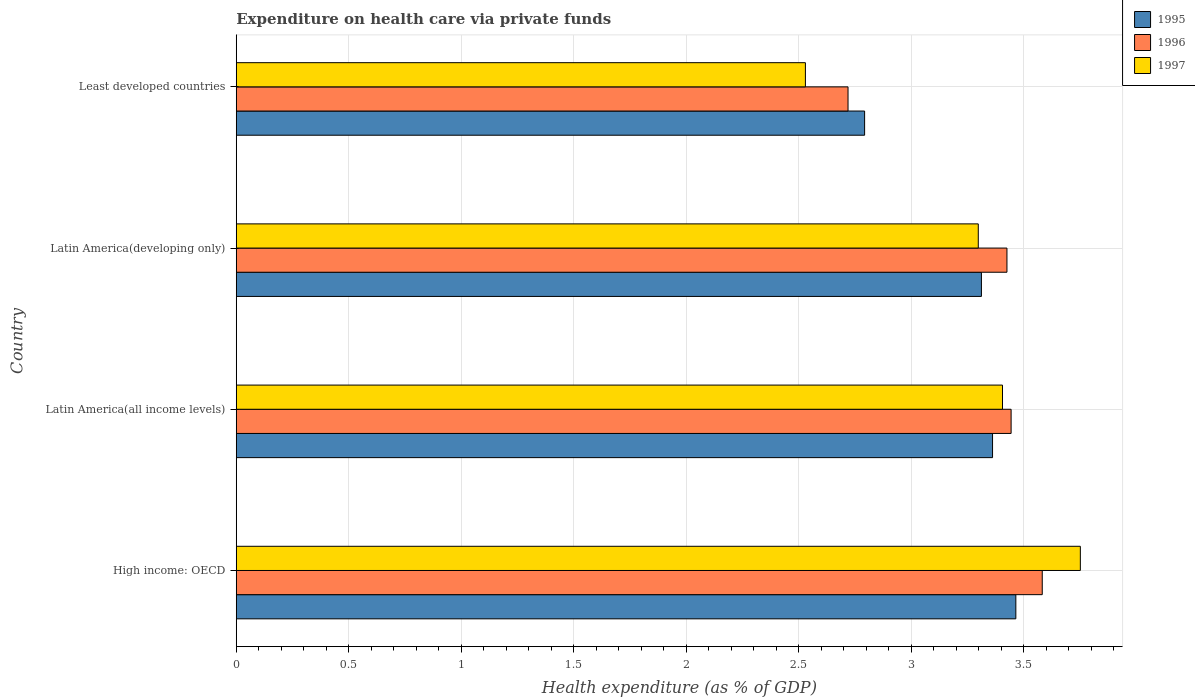How many different coloured bars are there?
Offer a very short reply. 3. Are the number of bars per tick equal to the number of legend labels?
Ensure brevity in your answer.  Yes. Are the number of bars on each tick of the Y-axis equal?
Your answer should be very brief. Yes. How many bars are there on the 3rd tick from the top?
Give a very brief answer. 3. How many bars are there on the 4th tick from the bottom?
Offer a terse response. 3. What is the label of the 1st group of bars from the top?
Provide a succinct answer. Least developed countries. In how many cases, is the number of bars for a given country not equal to the number of legend labels?
Provide a short and direct response. 0. What is the expenditure made on health care in 1997 in Latin America(all income levels)?
Your response must be concise. 3.41. Across all countries, what is the maximum expenditure made on health care in 1996?
Keep it short and to the point. 3.58. Across all countries, what is the minimum expenditure made on health care in 1996?
Offer a very short reply. 2.72. In which country was the expenditure made on health care in 1996 maximum?
Provide a short and direct response. High income: OECD. In which country was the expenditure made on health care in 1997 minimum?
Provide a short and direct response. Least developed countries. What is the total expenditure made on health care in 1995 in the graph?
Provide a short and direct response. 12.93. What is the difference between the expenditure made on health care in 1997 in Latin America(developing only) and that in Least developed countries?
Your answer should be very brief. 0.77. What is the difference between the expenditure made on health care in 1995 in Latin America(all income levels) and the expenditure made on health care in 1996 in Latin America(developing only)?
Offer a terse response. -0.06. What is the average expenditure made on health care in 1996 per country?
Your response must be concise. 3.29. What is the difference between the expenditure made on health care in 1995 and expenditure made on health care in 1996 in Least developed countries?
Provide a short and direct response. 0.07. What is the ratio of the expenditure made on health care in 1995 in Latin America(developing only) to that in Least developed countries?
Your answer should be compact. 1.19. What is the difference between the highest and the second highest expenditure made on health care in 1995?
Give a very brief answer. 0.1. What is the difference between the highest and the lowest expenditure made on health care in 1996?
Your response must be concise. 0.86. What does the 2nd bar from the top in Least developed countries represents?
Your response must be concise. 1996. What does the 3rd bar from the bottom in High income: OECD represents?
Offer a very short reply. 1997. Is it the case that in every country, the sum of the expenditure made on health care in 1997 and expenditure made on health care in 1996 is greater than the expenditure made on health care in 1995?
Your answer should be very brief. Yes. How many bars are there?
Provide a short and direct response. 12. What is the difference between two consecutive major ticks on the X-axis?
Provide a succinct answer. 0.5. Does the graph contain grids?
Make the answer very short. Yes. How many legend labels are there?
Make the answer very short. 3. What is the title of the graph?
Offer a very short reply. Expenditure on health care via private funds. Does "1978" appear as one of the legend labels in the graph?
Give a very brief answer. No. What is the label or title of the X-axis?
Your answer should be compact. Health expenditure (as % of GDP). What is the label or title of the Y-axis?
Your response must be concise. Country. What is the Health expenditure (as % of GDP) in 1995 in High income: OECD?
Offer a very short reply. 3.47. What is the Health expenditure (as % of GDP) of 1996 in High income: OECD?
Ensure brevity in your answer.  3.58. What is the Health expenditure (as % of GDP) of 1997 in High income: OECD?
Offer a terse response. 3.75. What is the Health expenditure (as % of GDP) in 1995 in Latin America(all income levels)?
Keep it short and to the point. 3.36. What is the Health expenditure (as % of GDP) in 1996 in Latin America(all income levels)?
Your answer should be compact. 3.44. What is the Health expenditure (as % of GDP) of 1997 in Latin America(all income levels)?
Your response must be concise. 3.41. What is the Health expenditure (as % of GDP) in 1995 in Latin America(developing only)?
Your answer should be very brief. 3.31. What is the Health expenditure (as % of GDP) of 1996 in Latin America(developing only)?
Ensure brevity in your answer.  3.43. What is the Health expenditure (as % of GDP) of 1997 in Latin America(developing only)?
Ensure brevity in your answer.  3.3. What is the Health expenditure (as % of GDP) in 1995 in Least developed countries?
Provide a short and direct response. 2.79. What is the Health expenditure (as % of GDP) in 1996 in Least developed countries?
Your response must be concise. 2.72. What is the Health expenditure (as % of GDP) in 1997 in Least developed countries?
Offer a very short reply. 2.53. Across all countries, what is the maximum Health expenditure (as % of GDP) in 1995?
Offer a very short reply. 3.47. Across all countries, what is the maximum Health expenditure (as % of GDP) of 1996?
Your answer should be compact. 3.58. Across all countries, what is the maximum Health expenditure (as % of GDP) in 1997?
Offer a terse response. 3.75. Across all countries, what is the minimum Health expenditure (as % of GDP) of 1995?
Offer a terse response. 2.79. Across all countries, what is the minimum Health expenditure (as % of GDP) in 1996?
Your response must be concise. 2.72. Across all countries, what is the minimum Health expenditure (as % of GDP) in 1997?
Make the answer very short. 2.53. What is the total Health expenditure (as % of GDP) of 1995 in the graph?
Your answer should be compact. 12.93. What is the total Health expenditure (as % of GDP) in 1996 in the graph?
Keep it short and to the point. 13.17. What is the total Health expenditure (as % of GDP) in 1997 in the graph?
Keep it short and to the point. 12.99. What is the difference between the Health expenditure (as % of GDP) in 1995 in High income: OECD and that in Latin America(all income levels)?
Your response must be concise. 0.1. What is the difference between the Health expenditure (as % of GDP) of 1996 in High income: OECD and that in Latin America(all income levels)?
Your answer should be compact. 0.14. What is the difference between the Health expenditure (as % of GDP) in 1997 in High income: OECD and that in Latin America(all income levels)?
Provide a succinct answer. 0.35. What is the difference between the Health expenditure (as % of GDP) in 1995 in High income: OECD and that in Latin America(developing only)?
Your answer should be compact. 0.15. What is the difference between the Health expenditure (as % of GDP) in 1996 in High income: OECD and that in Latin America(developing only)?
Give a very brief answer. 0.16. What is the difference between the Health expenditure (as % of GDP) of 1997 in High income: OECD and that in Latin America(developing only)?
Make the answer very short. 0.45. What is the difference between the Health expenditure (as % of GDP) in 1995 in High income: OECD and that in Least developed countries?
Offer a very short reply. 0.67. What is the difference between the Health expenditure (as % of GDP) in 1996 in High income: OECD and that in Least developed countries?
Give a very brief answer. 0.86. What is the difference between the Health expenditure (as % of GDP) in 1997 in High income: OECD and that in Least developed countries?
Your response must be concise. 1.22. What is the difference between the Health expenditure (as % of GDP) in 1995 in Latin America(all income levels) and that in Latin America(developing only)?
Ensure brevity in your answer.  0.05. What is the difference between the Health expenditure (as % of GDP) of 1996 in Latin America(all income levels) and that in Latin America(developing only)?
Provide a short and direct response. 0.02. What is the difference between the Health expenditure (as % of GDP) in 1997 in Latin America(all income levels) and that in Latin America(developing only)?
Offer a very short reply. 0.11. What is the difference between the Health expenditure (as % of GDP) of 1995 in Latin America(all income levels) and that in Least developed countries?
Make the answer very short. 0.57. What is the difference between the Health expenditure (as % of GDP) in 1996 in Latin America(all income levels) and that in Least developed countries?
Offer a terse response. 0.72. What is the difference between the Health expenditure (as % of GDP) of 1997 in Latin America(all income levels) and that in Least developed countries?
Make the answer very short. 0.88. What is the difference between the Health expenditure (as % of GDP) in 1995 in Latin America(developing only) and that in Least developed countries?
Provide a short and direct response. 0.52. What is the difference between the Health expenditure (as % of GDP) of 1996 in Latin America(developing only) and that in Least developed countries?
Provide a short and direct response. 0.71. What is the difference between the Health expenditure (as % of GDP) in 1997 in Latin America(developing only) and that in Least developed countries?
Make the answer very short. 0.77. What is the difference between the Health expenditure (as % of GDP) of 1995 in High income: OECD and the Health expenditure (as % of GDP) of 1996 in Latin America(all income levels)?
Your response must be concise. 0.02. What is the difference between the Health expenditure (as % of GDP) in 1995 in High income: OECD and the Health expenditure (as % of GDP) in 1997 in Latin America(all income levels)?
Make the answer very short. 0.06. What is the difference between the Health expenditure (as % of GDP) of 1996 in High income: OECD and the Health expenditure (as % of GDP) of 1997 in Latin America(all income levels)?
Ensure brevity in your answer.  0.18. What is the difference between the Health expenditure (as % of GDP) in 1995 in High income: OECD and the Health expenditure (as % of GDP) in 1996 in Latin America(developing only)?
Ensure brevity in your answer.  0.04. What is the difference between the Health expenditure (as % of GDP) of 1995 in High income: OECD and the Health expenditure (as % of GDP) of 1997 in Latin America(developing only)?
Provide a short and direct response. 0.17. What is the difference between the Health expenditure (as % of GDP) of 1996 in High income: OECD and the Health expenditure (as % of GDP) of 1997 in Latin America(developing only)?
Keep it short and to the point. 0.28. What is the difference between the Health expenditure (as % of GDP) in 1995 in High income: OECD and the Health expenditure (as % of GDP) in 1996 in Least developed countries?
Provide a succinct answer. 0.75. What is the difference between the Health expenditure (as % of GDP) of 1995 in High income: OECD and the Health expenditure (as % of GDP) of 1997 in Least developed countries?
Your answer should be compact. 0.94. What is the difference between the Health expenditure (as % of GDP) in 1996 in High income: OECD and the Health expenditure (as % of GDP) in 1997 in Least developed countries?
Your answer should be compact. 1.05. What is the difference between the Health expenditure (as % of GDP) in 1995 in Latin America(all income levels) and the Health expenditure (as % of GDP) in 1996 in Latin America(developing only)?
Give a very brief answer. -0.06. What is the difference between the Health expenditure (as % of GDP) of 1995 in Latin America(all income levels) and the Health expenditure (as % of GDP) of 1997 in Latin America(developing only)?
Your response must be concise. 0.06. What is the difference between the Health expenditure (as % of GDP) in 1996 in Latin America(all income levels) and the Health expenditure (as % of GDP) in 1997 in Latin America(developing only)?
Your answer should be compact. 0.15. What is the difference between the Health expenditure (as % of GDP) in 1995 in Latin America(all income levels) and the Health expenditure (as % of GDP) in 1996 in Least developed countries?
Provide a short and direct response. 0.64. What is the difference between the Health expenditure (as % of GDP) in 1995 in Latin America(all income levels) and the Health expenditure (as % of GDP) in 1997 in Least developed countries?
Give a very brief answer. 0.83. What is the difference between the Health expenditure (as % of GDP) of 1996 in Latin America(all income levels) and the Health expenditure (as % of GDP) of 1997 in Least developed countries?
Ensure brevity in your answer.  0.91. What is the difference between the Health expenditure (as % of GDP) in 1995 in Latin America(developing only) and the Health expenditure (as % of GDP) in 1996 in Least developed countries?
Give a very brief answer. 0.59. What is the difference between the Health expenditure (as % of GDP) of 1995 in Latin America(developing only) and the Health expenditure (as % of GDP) of 1997 in Least developed countries?
Provide a succinct answer. 0.78. What is the difference between the Health expenditure (as % of GDP) in 1996 in Latin America(developing only) and the Health expenditure (as % of GDP) in 1997 in Least developed countries?
Your answer should be very brief. 0.9. What is the average Health expenditure (as % of GDP) of 1995 per country?
Keep it short and to the point. 3.23. What is the average Health expenditure (as % of GDP) in 1996 per country?
Ensure brevity in your answer.  3.29. What is the average Health expenditure (as % of GDP) of 1997 per country?
Make the answer very short. 3.25. What is the difference between the Health expenditure (as % of GDP) of 1995 and Health expenditure (as % of GDP) of 1996 in High income: OECD?
Ensure brevity in your answer.  -0.12. What is the difference between the Health expenditure (as % of GDP) in 1995 and Health expenditure (as % of GDP) in 1997 in High income: OECD?
Keep it short and to the point. -0.29. What is the difference between the Health expenditure (as % of GDP) of 1996 and Health expenditure (as % of GDP) of 1997 in High income: OECD?
Provide a short and direct response. -0.17. What is the difference between the Health expenditure (as % of GDP) in 1995 and Health expenditure (as % of GDP) in 1996 in Latin America(all income levels)?
Make the answer very short. -0.08. What is the difference between the Health expenditure (as % of GDP) in 1995 and Health expenditure (as % of GDP) in 1997 in Latin America(all income levels)?
Make the answer very short. -0.04. What is the difference between the Health expenditure (as % of GDP) of 1996 and Health expenditure (as % of GDP) of 1997 in Latin America(all income levels)?
Make the answer very short. 0.04. What is the difference between the Health expenditure (as % of GDP) of 1995 and Health expenditure (as % of GDP) of 1996 in Latin America(developing only)?
Your answer should be very brief. -0.11. What is the difference between the Health expenditure (as % of GDP) in 1995 and Health expenditure (as % of GDP) in 1997 in Latin America(developing only)?
Ensure brevity in your answer.  0.01. What is the difference between the Health expenditure (as % of GDP) of 1996 and Health expenditure (as % of GDP) of 1997 in Latin America(developing only)?
Keep it short and to the point. 0.13. What is the difference between the Health expenditure (as % of GDP) in 1995 and Health expenditure (as % of GDP) in 1996 in Least developed countries?
Make the answer very short. 0.07. What is the difference between the Health expenditure (as % of GDP) of 1995 and Health expenditure (as % of GDP) of 1997 in Least developed countries?
Ensure brevity in your answer.  0.26. What is the difference between the Health expenditure (as % of GDP) in 1996 and Health expenditure (as % of GDP) in 1997 in Least developed countries?
Your response must be concise. 0.19. What is the ratio of the Health expenditure (as % of GDP) in 1995 in High income: OECD to that in Latin America(all income levels)?
Your response must be concise. 1.03. What is the ratio of the Health expenditure (as % of GDP) of 1996 in High income: OECD to that in Latin America(all income levels)?
Provide a short and direct response. 1.04. What is the ratio of the Health expenditure (as % of GDP) of 1997 in High income: OECD to that in Latin America(all income levels)?
Make the answer very short. 1.1. What is the ratio of the Health expenditure (as % of GDP) of 1995 in High income: OECD to that in Latin America(developing only)?
Your answer should be compact. 1.05. What is the ratio of the Health expenditure (as % of GDP) in 1996 in High income: OECD to that in Latin America(developing only)?
Give a very brief answer. 1.05. What is the ratio of the Health expenditure (as % of GDP) in 1997 in High income: OECD to that in Latin America(developing only)?
Make the answer very short. 1.14. What is the ratio of the Health expenditure (as % of GDP) of 1995 in High income: OECD to that in Least developed countries?
Give a very brief answer. 1.24. What is the ratio of the Health expenditure (as % of GDP) of 1996 in High income: OECD to that in Least developed countries?
Your answer should be compact. 1.32. What is the ratio of the Health expenditure (as % of GDP) of 1997 in High income: OECD to that in Least developed countries?
Offer a terse response. 1.48. What is the ratio of the Health expenditure (as % of GDP) in 1995 in Latin America(all income levels) to that in Latin America(developing only)?
Offer a terse response. 1.01. What is the ratio of the Health expenditure (as % of GDP) in 1996 in Latin America(all income levels) to that in Latin America(developing only)?
Provide a succinct answer. 1.01. What is the ratio of the Health expenditure (as % of GDP) of 1997 in Latin America(all income levels) to that in Latin America(developing only)?
Provide a short and direct response. 1.03. What is the ratio of the Health expenditure (as % of GDP) in 1995 in Latin America(all income levels) to that in Least developed countries?
Provide a short and direct response. 1.2. What is the ratio of the Health expenditure (as % of GDP) in 1996 in Latin America(all income levels) to that in Least developed countries?
Your answer should be very brief. 1.27. What is the ratio of the Health expenditure (as % of GDP) in 1997 in Latin America(all income levels) to that in Least developed countries?
Provide a succinct answer. 1.35. What is the ratio of the Health expenditure (as % of GDP) in 1995 in Latin America(developing only) to that in Least developed countries?
Offer a very short reply. 1.19. What is the ratio of the Health expenditure (as % of GDP) of 1996 in Latin America(developing only) to that in Least developed countries?
Offer a very short reply. 1.26. What is the ratio of the Health expenditure (as % of GDP) of 1997 in Latin America(developing only) to that in Least developed countries?
Offer a terse response. 1.3. What is the difference between the highest and the second highest Health expenditure (as % of GDP) of 1995?
Make the answer very short. 0.1. What is the difference between the highest and the second highest Health expenditure (as % of GDP) of 1996?
Make the answer very short. 0.14. What is the difference between the highest and the second highest Health expenditure (as % of GDP) in 1997?
Your response must be concise. 0.35. What is the difference between the highest and the lowest Health expenditure (as % of GDP) in 1995?
Provide a succinct answer. 0.67. What is the difference between the highest and the lowest Health expenditure (as % of GDP) in 1996?
Ensure brevity in your answer.  0.86. What is the difference between the highest and the lowest Health expenditure (as % of GDP) in 1997?
Your answer should be compact. 1.22. 